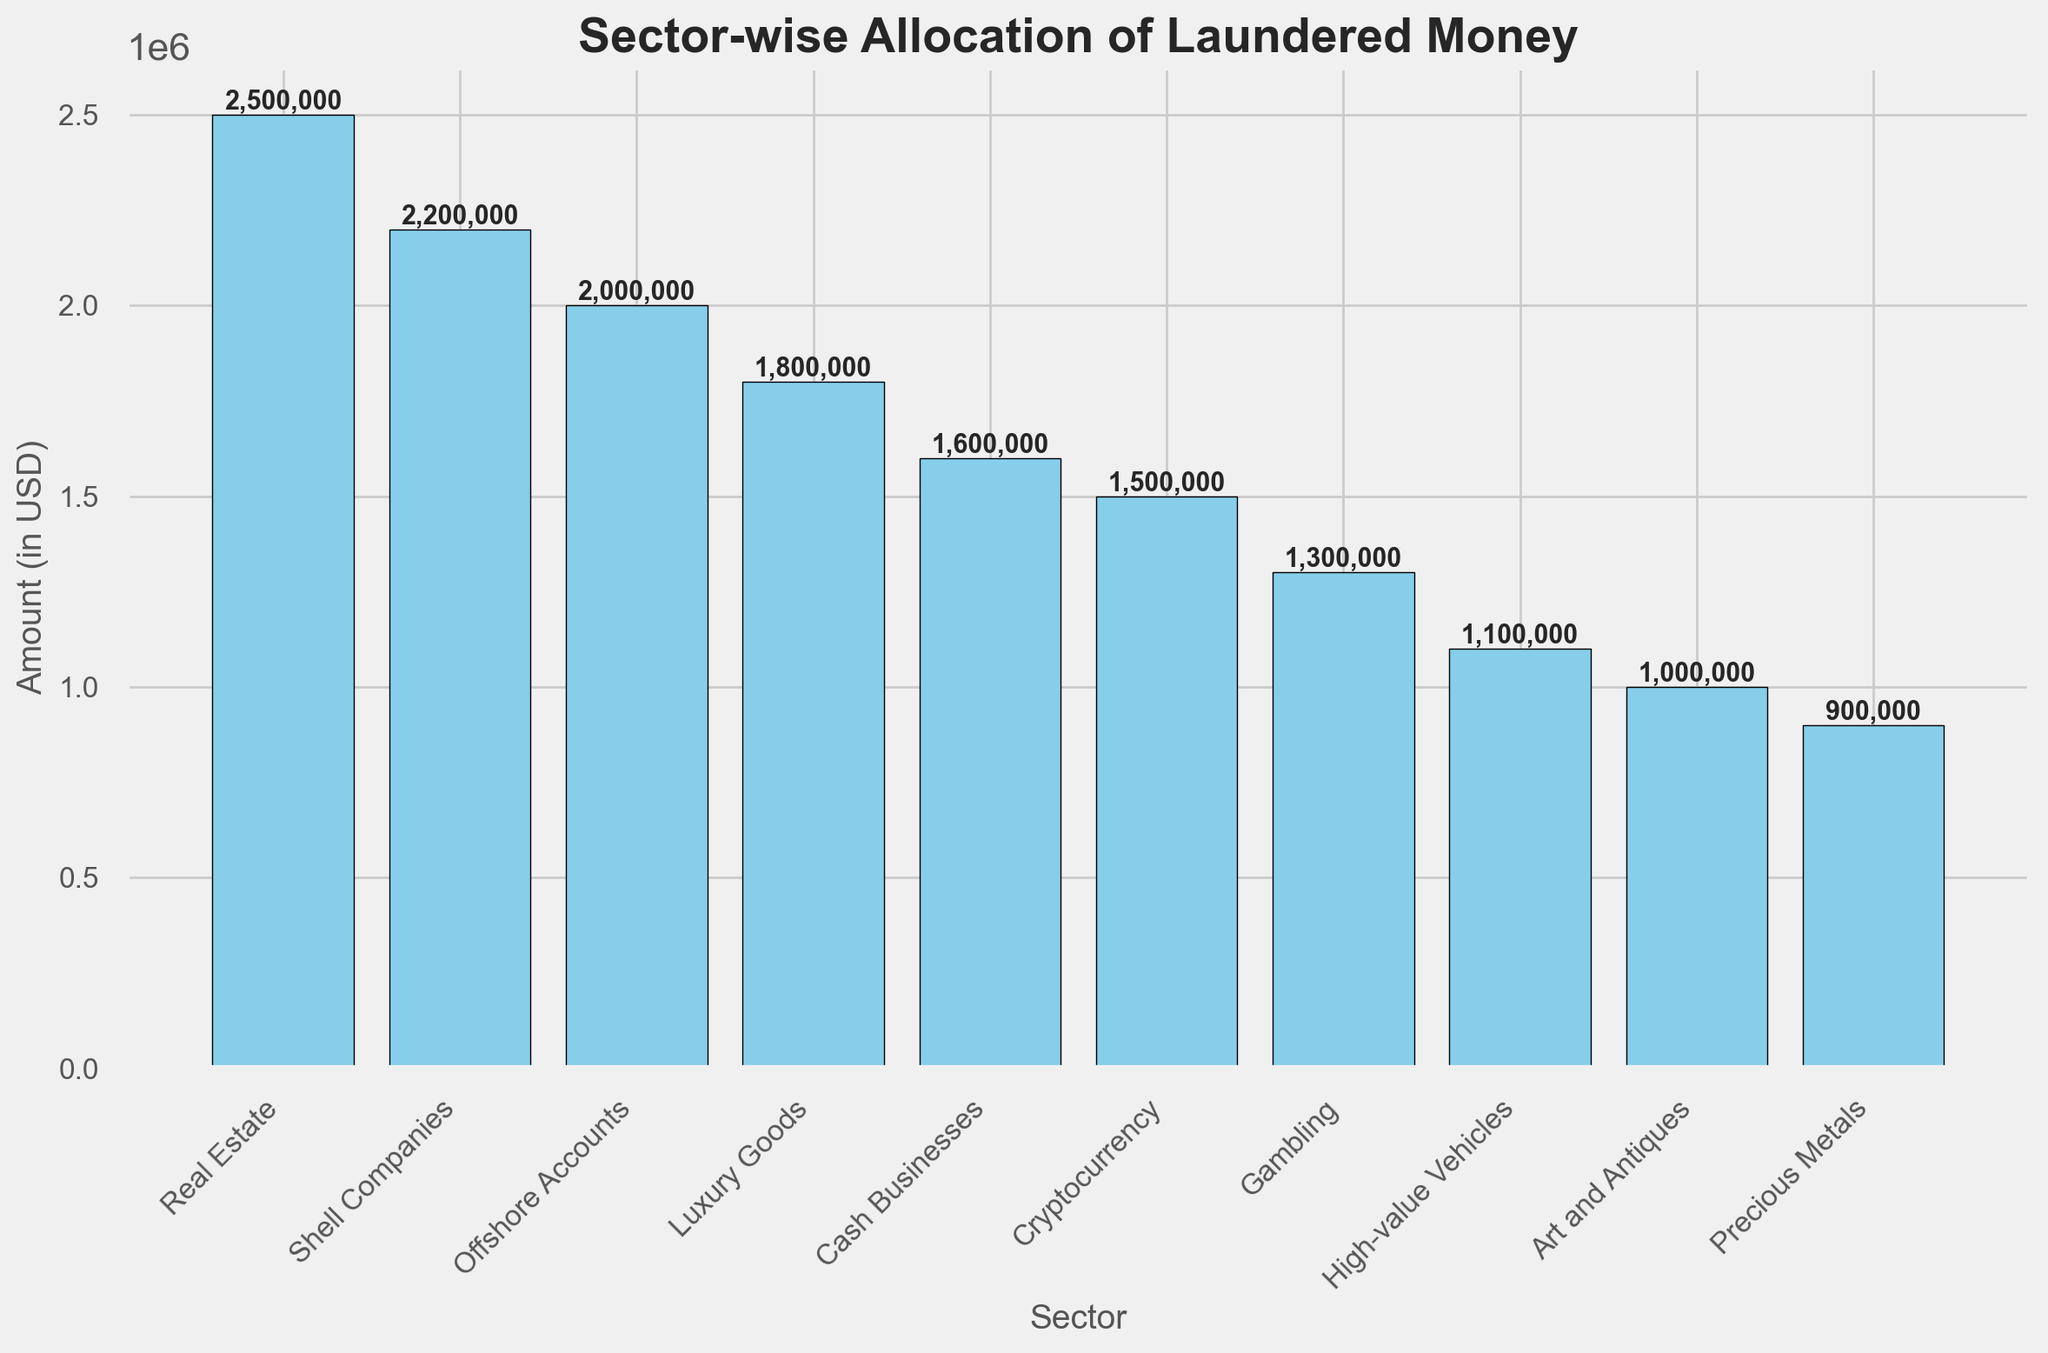What sector has the highest allocation of laundered money? By examining the bar chart, the highest bar represents the sector with the largest amount. The Real Estate sector's bar is the tallest, indicating it has the highest allocation.
Answer: Real Estate How much more money is allocated to Shell Companies than to Precious Metals? The bar for Shell Companies shows $2,200,000 and the bar for Precious Metals shows $900,000. The difference is $2,200,000 - $900,000 = $1,300,000.
Answer: $1,300,000 What is the total amount of laundered money allocated to Art and Antiques, Cryptocurrency, and Gambling combined? Adding the amounts for the three sectors: Art and Antiques ($1,000,000), Cryptocurrency ($1,500,000), and Gambling ($1,300,000) gives a total of $1,000,000 + $1,500,000 + $1,300,000 = $3,800,000.
Answer: $3,800,000 Which sector has the smallest allocation, and how much is it? The shortest bar identifies the sector with the smallest allocation. The bar for Precious Metals is the shortest, indicating it has the smallest allocation, which is $900,000.
Answer: Precious Metals, $900,000 What is the average allocation of laundered money across all sectors? Sum the amounts for all sectors and divide by the number of sectors. The total is $2,500,000 + $1,800,000 + $1,000,000 + $2,200,000 + $1,500,000 + $1,300,000 + $1,600,000 + $2,000,000 + $1,100,000 + $900,000 = $15,900,000. There are 10 sectors, so the average is $15,900,000 / 10 = $1,590,000.
Answer: $1,590,000 Is the amount allocated to Cash Businesses higher or lower than that for Offshore Accounts, and by how much? Comparing the bars for Cash Businesses ($1,600,000) and Offshore Accounts ($2,000,000), Cash Businesses receive less. The difference is $2,000,000 - $1,600,000 = $400,000.
Answer: Lower, $400,000 What is the difference in allocation between the sector with the second-highest and the sector with the second-lowest amounts? The second-highest allocation is for Shell Companies ($2,200,000) and the second-lowest is for Precious Metals ($900,000). The difference is $2,200,000 - $900,000 = $1,300,000.
Answer: $1,300,000 How does the amount of money in Offshore Accounts compare to that in High-value Vehicles? Offshore Accounts have an allocation of $2,000,000, and High-value Vehicles have an allocation of $1,100,000. Offshore Accounts have $2,000,000 - $1,100,000 = $900,000 more.
Answer: $900,000 more 